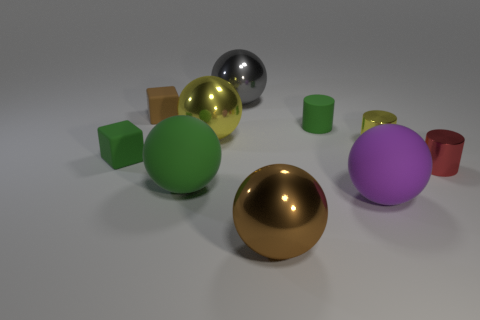How does the choice of colors impact the composition of the scene? The choice of colors creates a harmonious yet varied visual palette that gives the scene a playful and balanced aesthetic. The colors are well-distributed, ensuring that no single object dominates the view. Warmer colors, like the yellow cube and the gold sphere, draw the eye, while cooler tones, such as the green cylinder and purple sphere, provide a sense of calm, creating a pleasing contrast. 